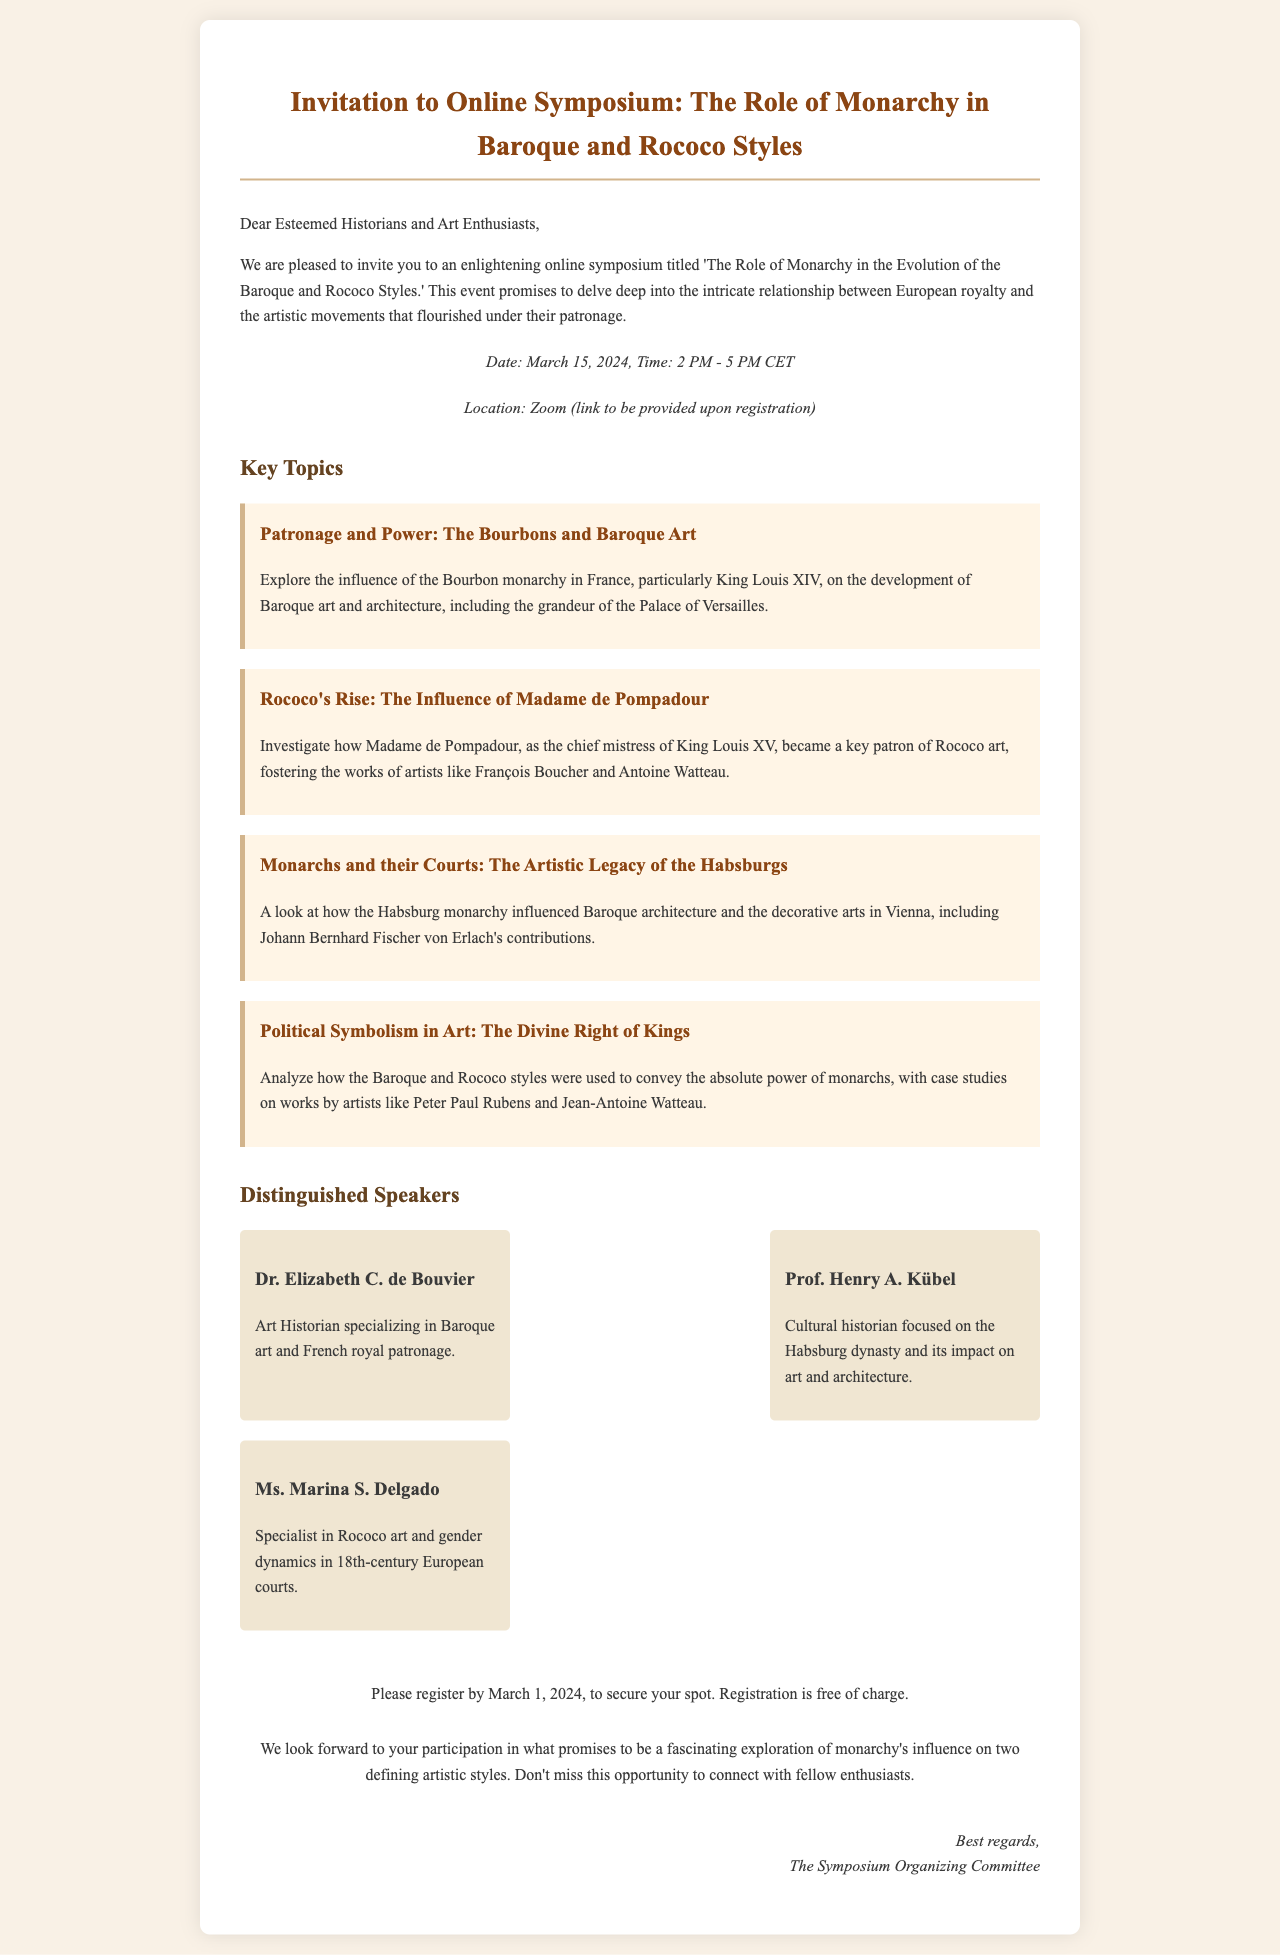What is the title of the symposium? The title of the symposium is explicitly stated in the invitation, which is "The Role of Monarchy in the Evolution of the Baroque and Rococo Styles."
Answer: The Role of Monarchy in the Evolution of the Baroque and Rococo Styles When is the symposium scheduled? The date is clearly mentioned in the document as March 15, 2024.
Answer: March 15, 2024 Who is one of the speakers? The document lists several speakers, including Dr. Elizabeth C. de Bouvier, specified as specializing in Baroque art and French royal patronage.
Answer: Dr. Elizabeth C. de Bouvier What platform will the symposium be held on? The invitation states that the location for the symposium will be Zoom.
Answer: Zoom What is the registration deadline? The invitation specifies that participants should register by March 1, 2024, to secure their spot.
Answer: March 1, 2024 What is a key topic discussed relating to Madame de Pompadour? The document mentions a topic that investigates Madame de Pompadour's role in Rococo art and artists.
Answer: The Influence of Madame de Pompadour How long will the symposium last? The document states the time for the symposium is from 2 PM to 5 PM CET, which is three hours.
Answer: 3 hours What does the registration cost? The invitation states that registration is free of charge.
Answer: Free of charge What is one aspect explored under the influence of the Habsburg monarchy? The invitation states the exploration of Habsburg monarchy's impact involves Baroque architecture and decorative arts in Vienna.
Answer: Baroque architecture and decorative arts in Vienna 